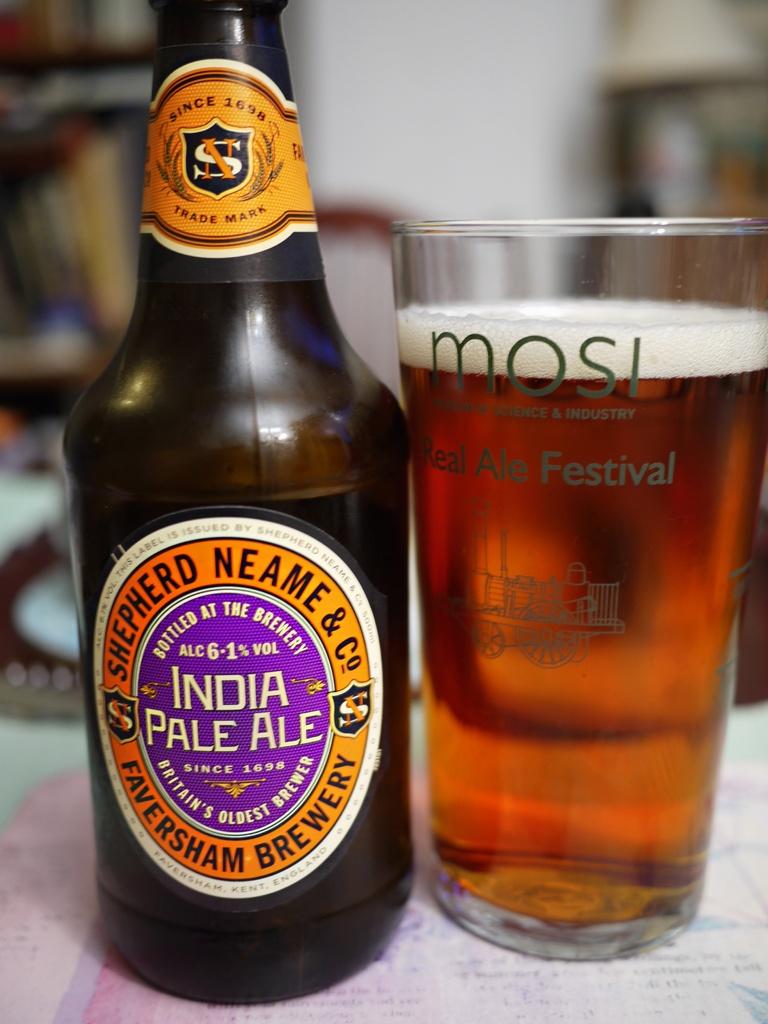Is this an ipa?
Keep it short and to the point. Yes. 